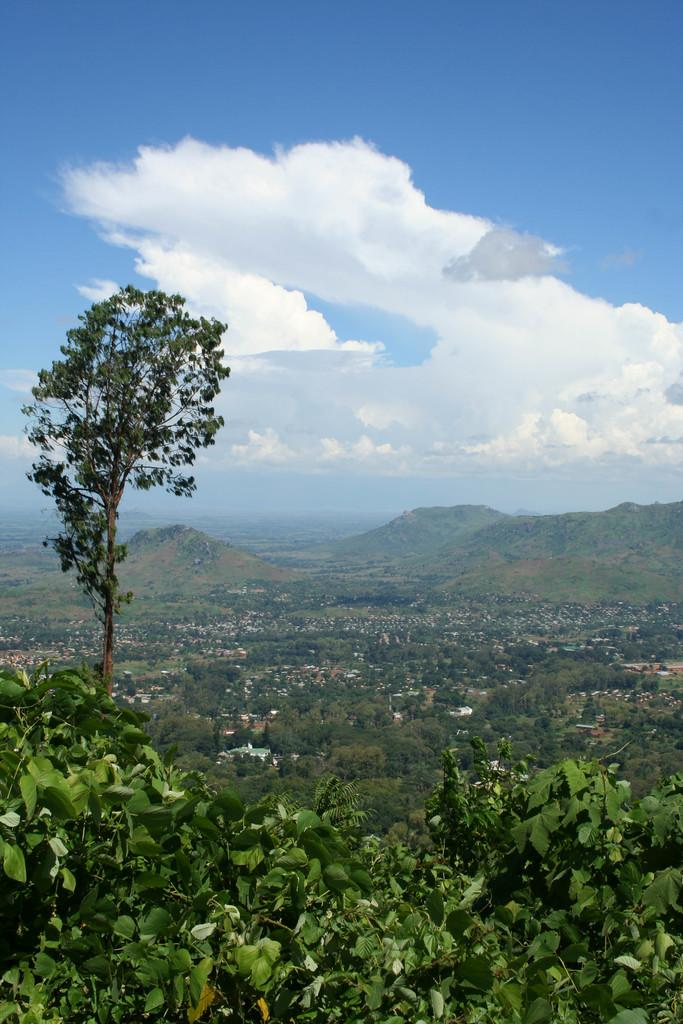What type of vegetation can be seen in the image? There are plants and a tree in the image. How many trees are visible in the image? There is one tree in the image, and multiple trees can be seen in the background. What else can be seen in the background of the image? There are houses and the sky visible in the background of the image. What type of trade is being conducted in the image? There is no indication of any trade being conducted in the image; it primarily features plants, trees, houses, and the sky. What does the image smell like? The image does not have a smell, as it is a visual representation. 